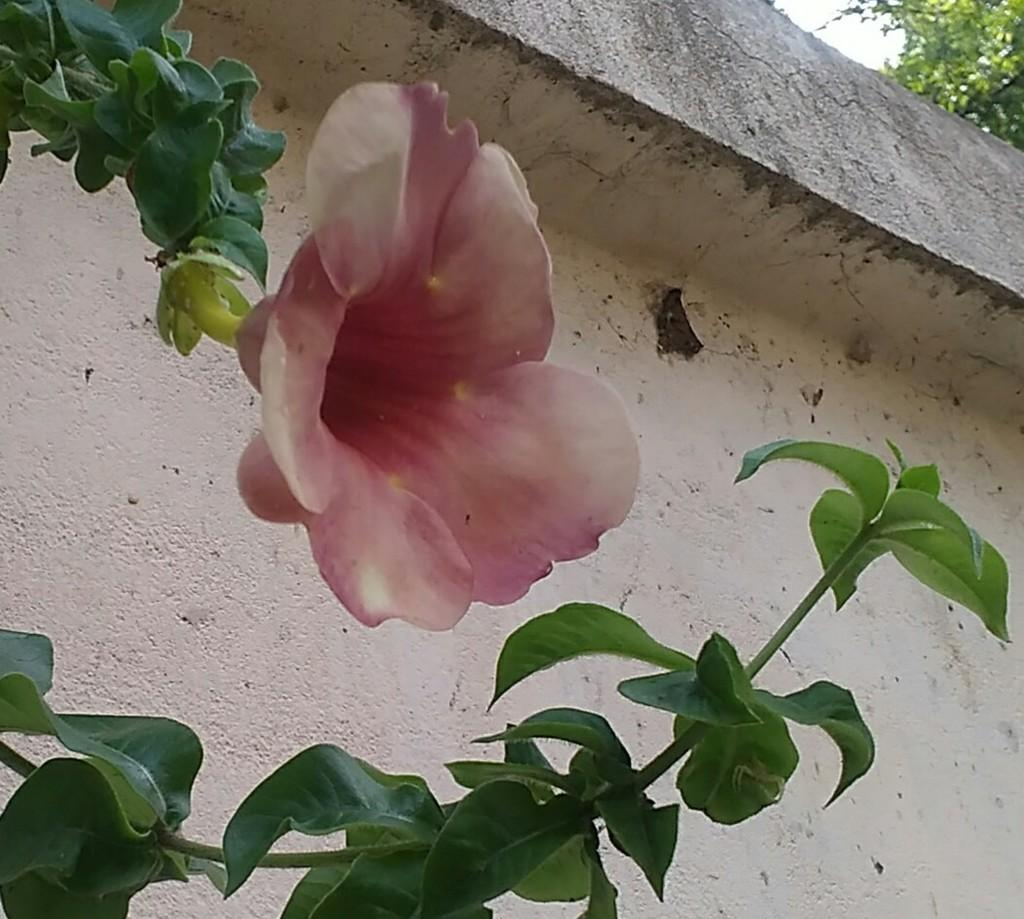What type of plant can be seen in the image? There is a flower in the image. Are there any other plants visible in the image? Yes, there are plants in the image. What is the background of the image? There is a wall in the image, and a tree can be seen in the background. How many eggs are present in the image? There are no eggs visible in the image. 